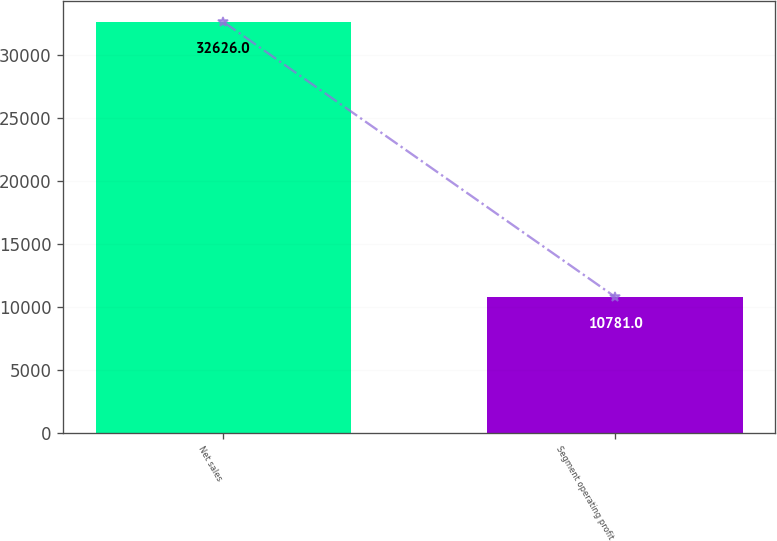Convert chart. <chart><loc_0><loc_0><loc_500><loc_500><bar_chart><fcel>Net sales<fcel>Segment operating profit<nl><fcel>32626<fcel>10781<nl></chart> 